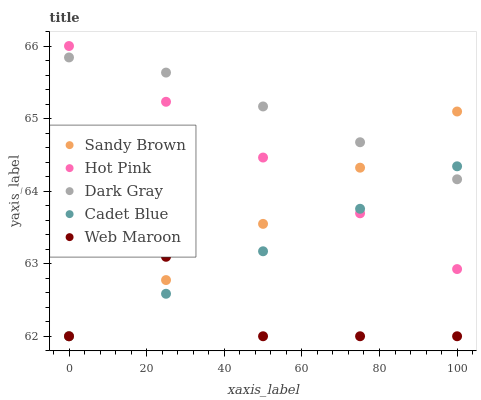Does Web Maroon have the minimum area under the curve?
Answer yes or no. Yes. Does Dark Gray have the maximum area under the curve?
Answer yes or no. Yes. Does Hot Pink have the minimum area under the curve?
Answer yes or no. No. Does Hot Pink have the maximum area under the curve?
Answer yes or no. No. Is Hot Pink the smoothest?
Answer yes or no. Yes. Is Web Maroon the roughest?
Answer yes or no. Yes. Is Web Maroon the smoothest?
Answer yes or no. No. Is Hot Pink the roughest?
Answer yes or no. No. Does Web Maroon have the lowest value?
Answer yes or no. Yes. Does Hot Pink have the lowest value?
Answer yes or no. No. Does Hot Pink have the highest value?
Answer yes or no. Yes. Does Web Maroon have the highest value?
Answer yes or no. No. Is Web Maroon less than Hot Pink?
Answer yes or no. Yes. Is Dark Gray greater than Web Maroon?
Answer yes or no. Yes. Does Web Maroon intersect Sandy Brown?
Answer yes or no. Yes. Is Web Maroon less than Sandy Brown?
Answer yes or no. No. Is Web Maroon greater than Sandy Brown?
Answer yes or no. No. Does Web Maroon intersect Hot Pink?
Answer yes or no. No. 